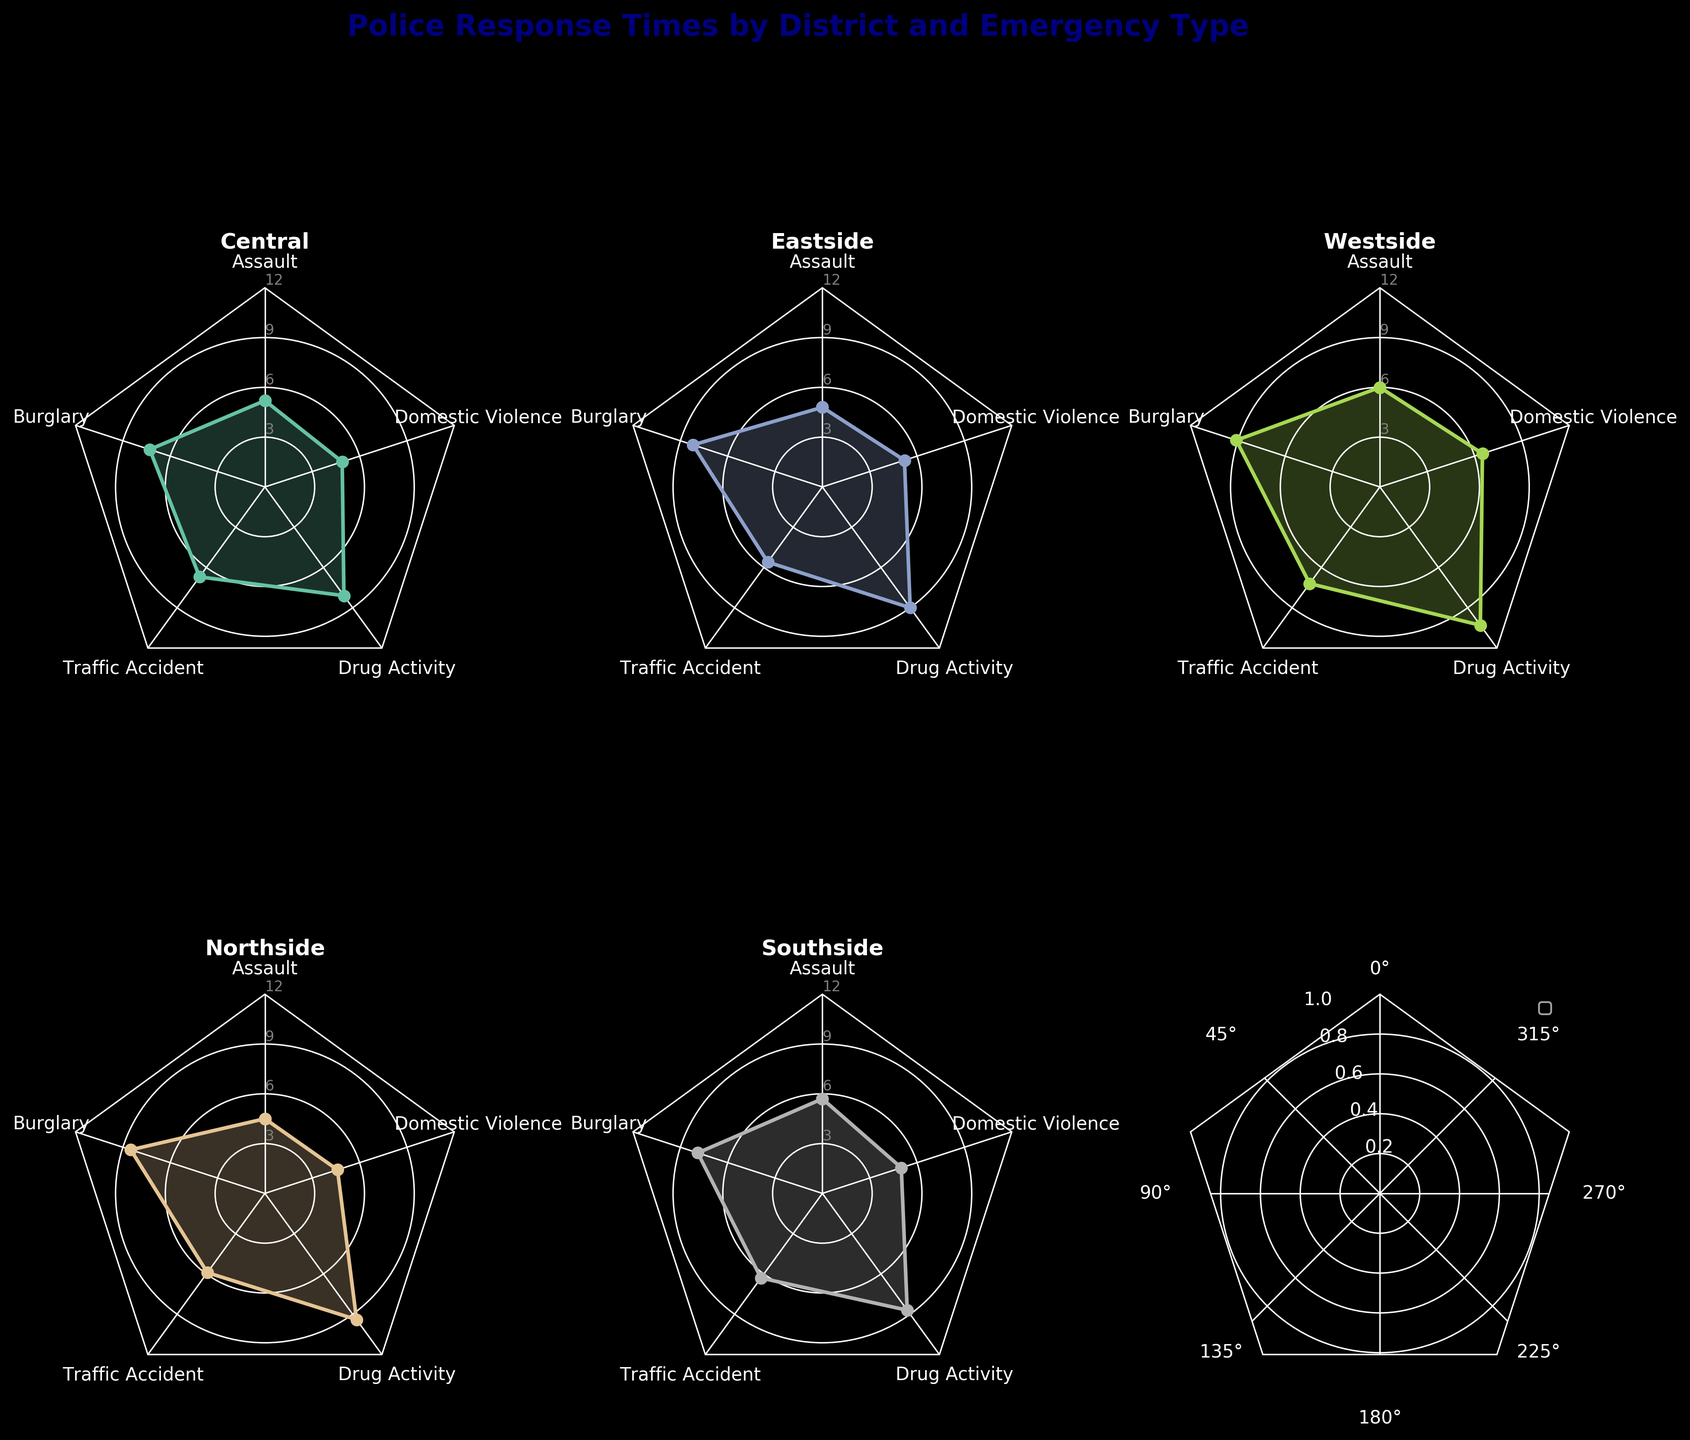What's the title of the figure? The title is usually displayed at the top of the figure. Here, it reads "Police Response Times by District and Emergency Type".
Answer: Police Response Times by District and Emergency Type Which district has the highest response time for Drug Activity? In each subplot, we can observe response times for various emergencies. The radar chart for Westside shows the highest response time for Drug Activity.
Answer: Westside What is the average response time for Domestic Violence across all districts? To find the average response time, sum the response times for Domestic Violence from all districts (4.9 + 5.2 + 6.5 + 4.6 + 5.0) and divide by the number of districts (5).
Answer: 5.24 Which emergency type has the most consistent response times across all districts? Looking at the radar charts, Traffic Accident response times seem to cluster closely together, indicating consistency across districts. The values range from 5.6 to 7.2.
Answer: Traffic Accident How does the response time for Burglary in Eastside compare to that in Central? Looking at the charts, the response time for Burglary in Eastside is 8.2 minutes, compared to 7.3 minutes in Central, making Eastside's response time higher.
Answer: Eastside is higher What's the difference in response times for Assault between the fastest (Northside) and slowest (Westside) districts? Northside's response time for Assault is 4.5 minutes, while Westside's is 6.0 minutes. The difference is 6.0 - 4.5 = 1.5 minutes.
Answer: 1.5 minutes Which district has the lowest overall response time for all emergencies? By visually comparing the charts, we can see that Northside consistently shows lower times for each emergency type.
Answer: Northside Feature all districts with their maximum response times above 9 minutes for any emergency type. Checking each subplot, we see that Eastside, Westside, and Northside have response times above 9 minutes for Drug Activity and Burglary in Westside.
Answer: Eastside, Westside, Northside Comparing Central and Southside, which district has a quicker response time for Domestic Violence? The radar chart shows Central with a Domestic Violence response time of 4.9 minutes and Southside at 5.0 minutes. Central is quicker by 0.1 minutes.
Answer: Central 